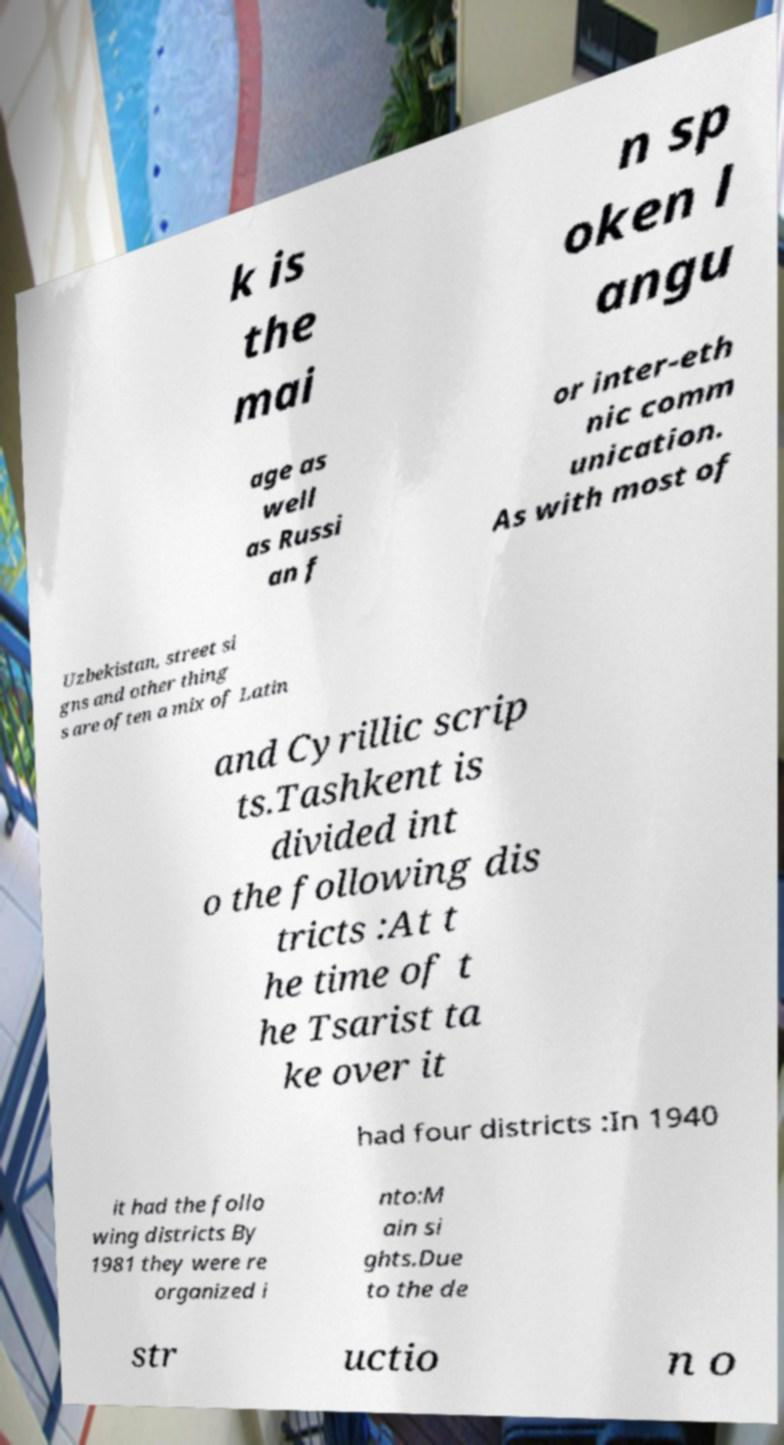Can you read and provide the text displayed in the image?This photo seems to have some interesting text. Can you extract and type it out for me? k is the mai n sp oken l angu age as well as Russi an f or inter-eth nic comm unication. As with most of Uzbekistan, street si gns and other thing s are often a mix of Latin and Cyrillic scrip ts.Tashkent is divided int o the following dis tricts :At t he time of t he Tsarist ta ke over it had four districts :In 1940 it had the follo wing districts By 1981 they were re organized i nto:M ain si ghts.Due to the de str uctio n o 